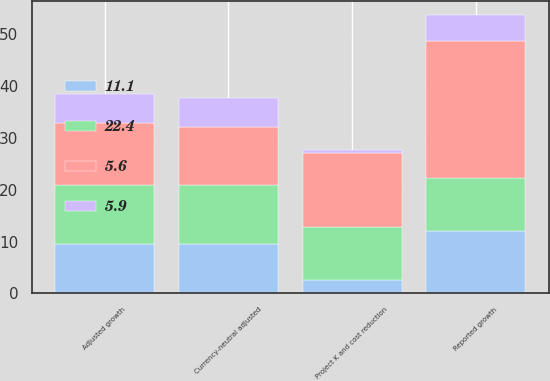<chart> <loc_0><loc_0><loc_500><loc_500><stacked_bar_chart><ecel><fcel>Reported growth<fcel>Project K and cost reduction<fcel>Adjusted growth<fcel>Currency-neutral adjusted<nl><fcel>22.4<fcel>10.3<fcel>10.3<fcel>11.4<fcel>11.4<nl><fcel>5.9<fcel>5<fcel>0.6<fcel>5.6<fcel>5.6<nl><fcel>11.1<fcel>12<fcel>2.5<fcel>9.5<fcel>9.5<nl><fcel>5.6<fcel>26.3<fcel>14.3<fcel>12<fcel>11.1<nl></chart> 